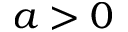Convert formula to latex. <formula><loc_0><loc_0><loc_500><loc_500>a > 0</formula> 